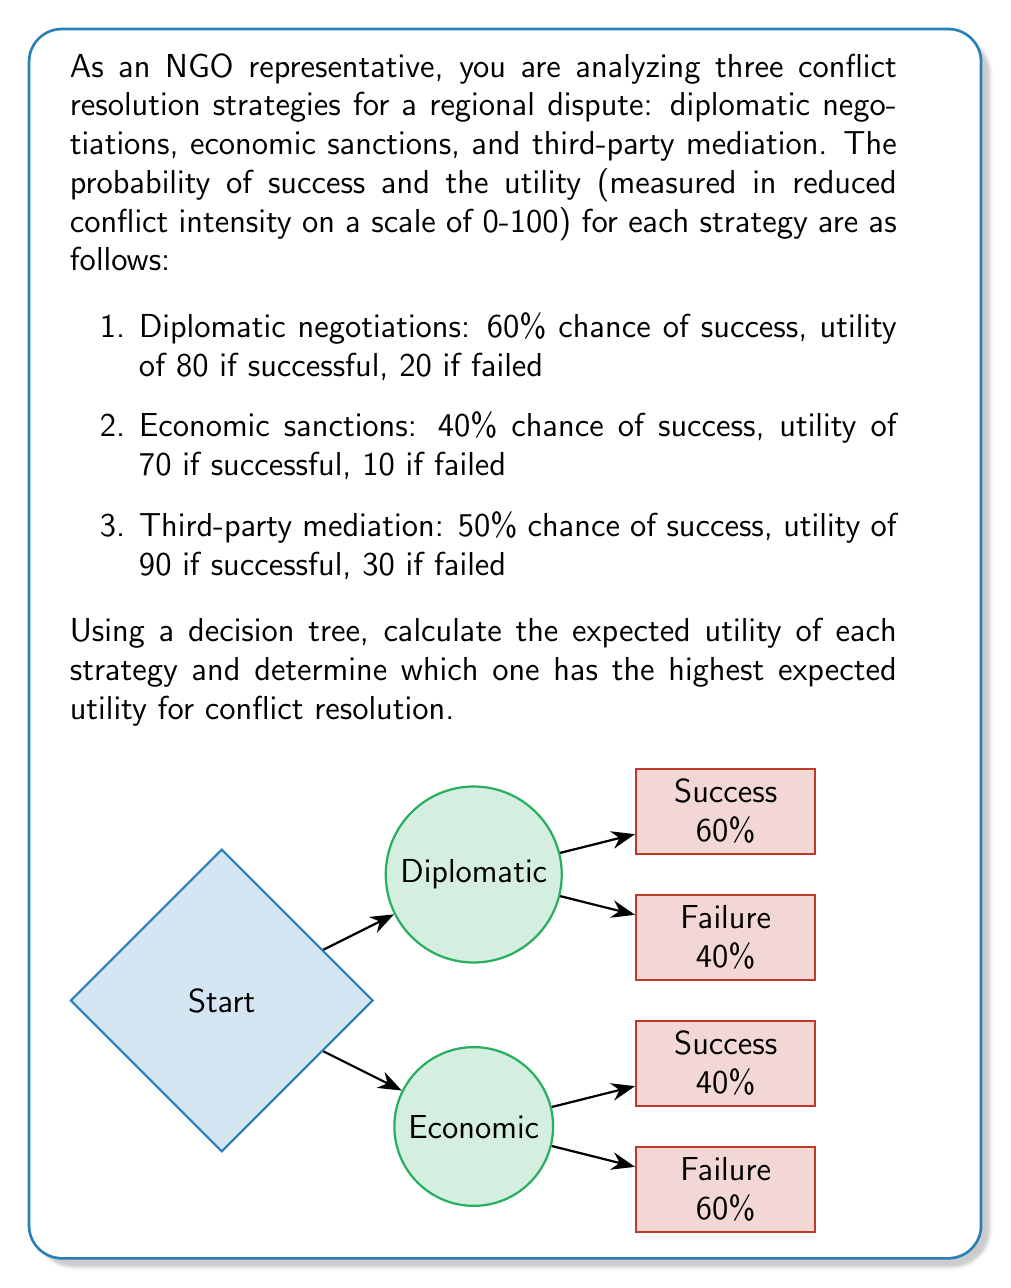Solve this math problem. To solve this problem, we need to calculate the expected utility for each strategy using the given probabilities and utilities. The expected utility is the sum of the products of each outcome's probability and its corresponding utility.

1. Diplomatic negotiations:
   - Success: $0.60 \times 80 = 48$
   - Failure: $0.40 \times 20 = 8$
   Expected Utility = $48 + 8 = 56$

2. Economic sanctions:
   - Success: $0.40 \times 70 = 28$
   - Failure: $0.60 \times 10 = 6$
   Expected Utility = $28 + 6 = 34$

3. Third-party mediation:
   - Success: $0.50 \times 90 = 45$
   - Failure: $0.50 \times 30 = 15$
   Expected Utility = $45 + 15 = 60$

The expected utility for each strategy can be calculated using the following formula:

$$E(U) = P(\text{success}) \times U(\text{success}) + P(\text{failure}) \times U(\text{failure})$$

Where:
- $E(U)$ is the expected utility
- $P(\text{success})$ is the probability of success
- $U(\text{success})$ is the utility of success
- $P(\text{failure})$ is the probability of failure
- $U(\text{failure})$ is the utility of failure

Comparing the expected utilities:
- Diplomatic negotiations: 56
- Economic sanctions: 34
- Third-party mediation: 60

Therefore, the strategy with the highest expected utility is third-party mediation with an expected utility of 60.
Answer: Third-party mediation, with an expected utility of 60. 